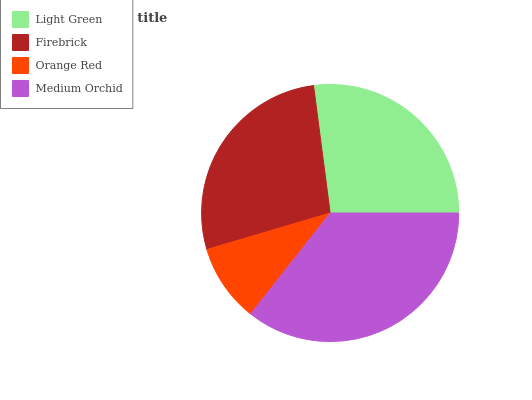Is Orange Red the minimum?
Answer yes or no. Yes. Is Medium Orchid the maximum?
Answer yes or no. Yes. Is Firebrick the minimum?
Answer yes or no. No. Is Firebrick the maximum?
Answer yes or no. No. Is Firebrick greater than Light Green?
Answer yes or no. Yes. Is Light Green less than Firebrick?
Answer yes or no. Yes. Is Light Green greater than Firebrick?
Answer yes or no. No. Is Firebrick less than Light Green?
Answer yes or no. No. Is Firebrick the high median?
Answer yes or no. Yes. Is Light Green the low median?
Answer yes or no. Yes. Is Light Green the high median?
Answer yes or no. No. Is Firebrick the low median?
Answer yes or no. No. 